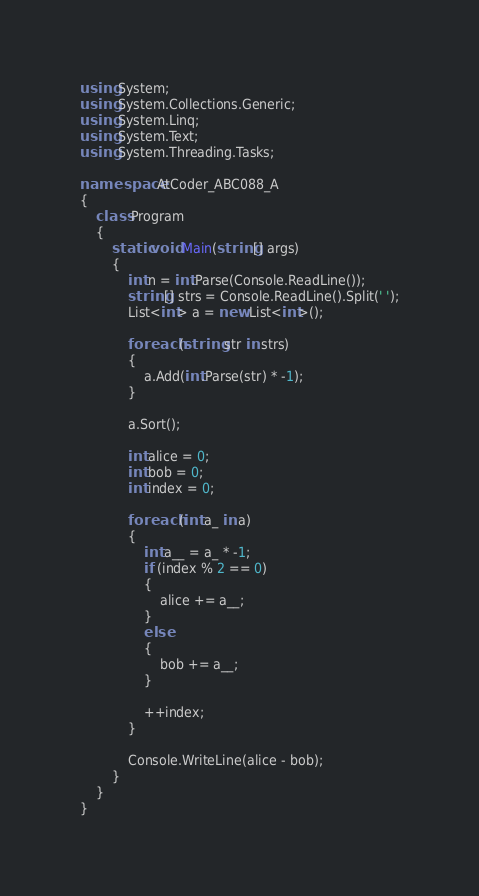<code> <loc_0><loc_0><loc_500><loc_500><_C#_>using System;
using System.Collections.Generic;
using System.Linq;
using System.Text;
using System.Threading.Tasks;

namespace AtCoder_ABC088_A
{
    class Program
    {
        static void Main(string[] args)
        {
            int n = int.Parse(Console.ReadLine());
            string[] strs = Console.ReadLine().Split(' ');
            List<int> a = new List<int>();

            foreach (string str in strs)
            {
                a.Add(int.Parse(str) * -1);
            }

            a.Sort();

            int alice = 0;
            int bob = 0;
            int index = 0;

            foreach (int a_ in a)
            {
                int a__ = a_ * -1;
                if (index % 2 == 0)
                {
                    alice += a__;
                }
                else
                {
                    bob += a__;
                }

                ++index;
            }

            Console.WriteLine(alice - bob);
        }
    }
}
</code> 